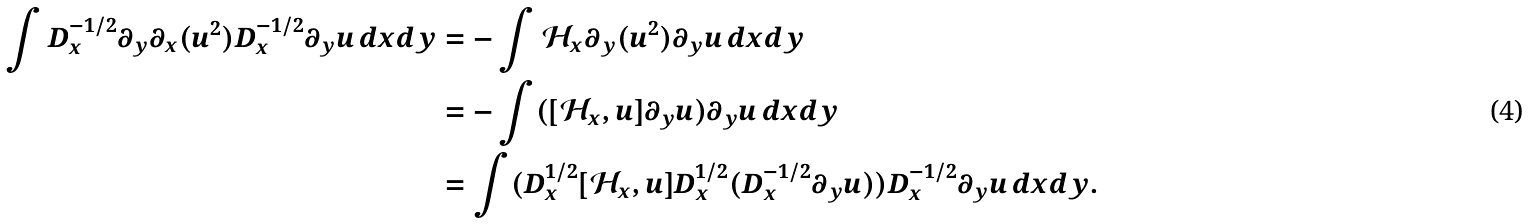<formula> <loc_0><loc_0><loc_500><loc_500>\int D _ { x } ^ { - 1 / 2 } \partial _ { y } \partial _ { x } ( u ^ { 2 } ) D _ { x } ^ { - 1 / 2 } \partial _ { y } u \, d x d y & = - \int \mathcal { H } _ { x } \partial _ { y } ( u ^ { 2 } ) \partial _ { y } u \, d x d y \\ & = - \int ( [ \mathcal { H } _ { x } , u ] \partial _ { y } u ) \partial _ { y } u \, d x d y \\ & = \int ( D _ { x } ^ { 1 / 2 } [ \mathcal { H } _ { x } , u ] D _ { x } ^ { 1 / 2 } ( D ^ { - 1 / 2 } _ { x } \partial _ { y } u ) ) D _ { x } ^ { - 1 / 2 } \partial _ { y } u \, d x d y .</formula> 